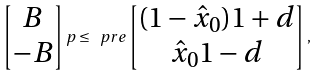Convert formula to latex. <formula><loc_0><loc_0><loc_500><loc_500>\begin{bmatrix} B \\ - B \end{bmatrix} p \leq \ p r e \begin{bmatrix} ( 1 - \hat { x } _ { 0 } ) 1 + d \\ \hat { x } _ { 0 } 1 - d \end{bmatrix} ,</formula> 